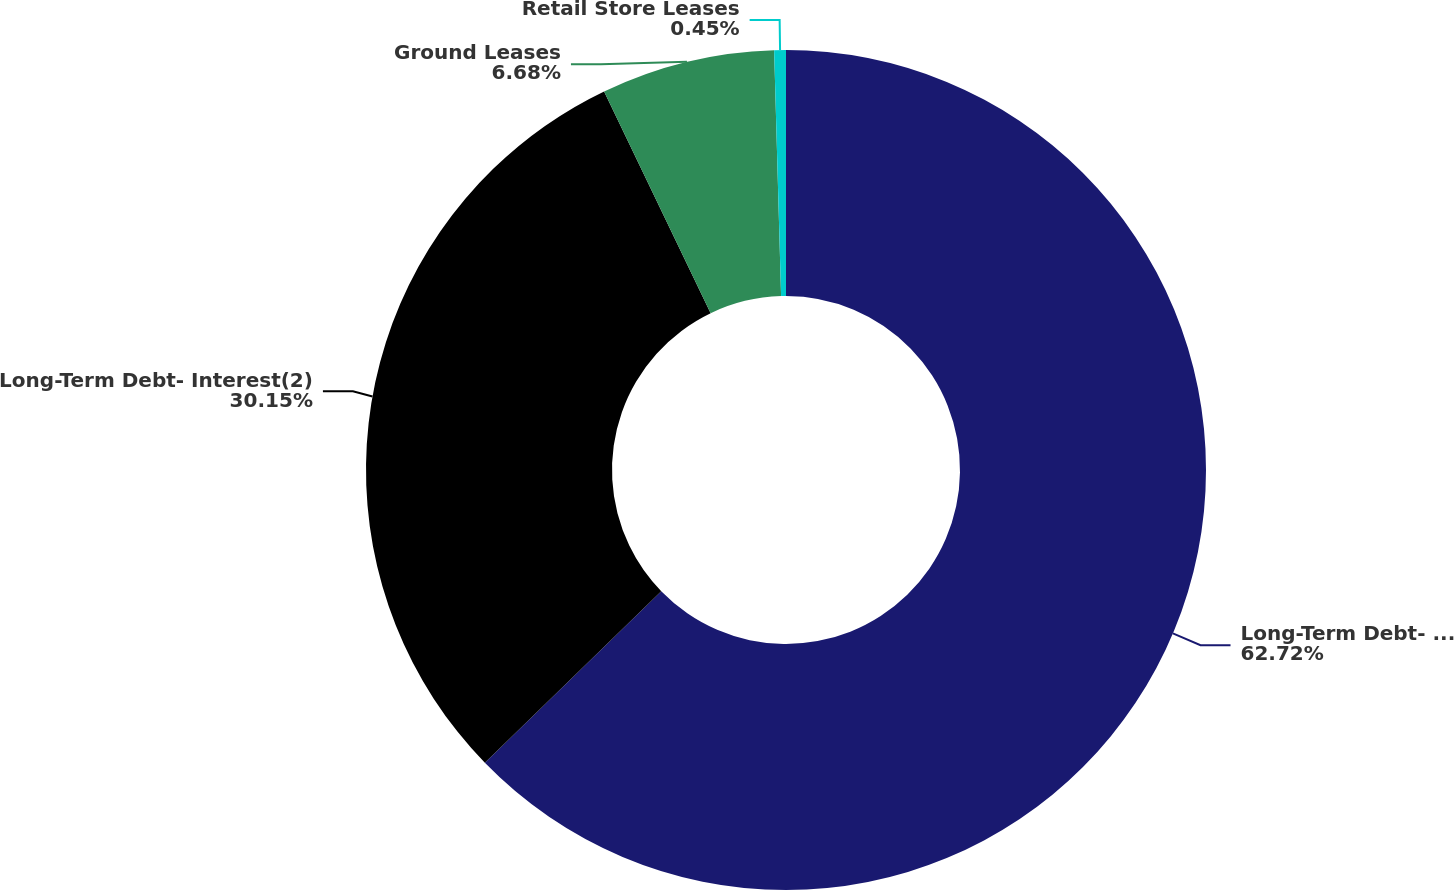Convert chart. <chart><loc_0><loc_0><loc_500><loc_500><pie_chart><fcel>Long-Term Debt- Principal(1)<fcel>Long-Term Debt- Interest(2)<fcel>Ground Leases<fcel>Retail Store Leases<nl><fcel>62.73%<fcel>30.15%<fcel>6.68%<fcel>0.45%<nl></chart> 